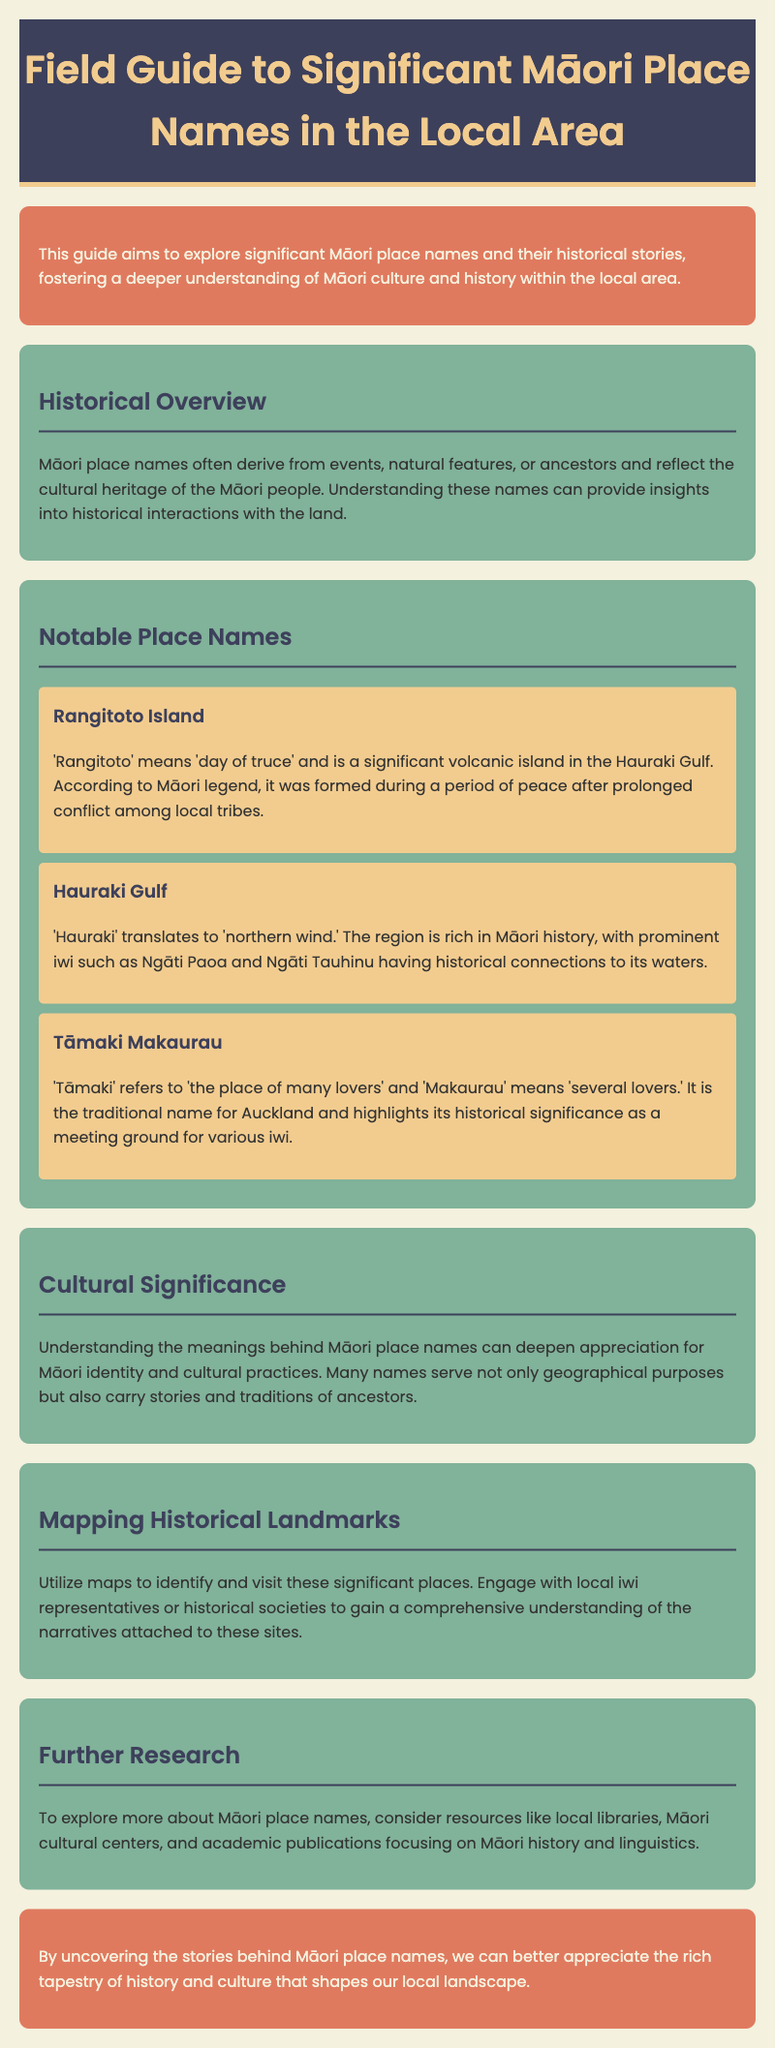What does 'Rangitoto' mean? 'Rangitoto' means 'day of truce' according to the document.
Answer: day of truce Which iwi are connected to the Hauraki Gulf? The document mentions Ngāti Paoa and Ngāti Tauhinu as iwi connected to the Hauraki Gulf.
Answer: Ngāti Paoa and Ngāti Tauhinu What is the traditional name for Auckland? The document states that 'Tāmaki Makaurau' is the traditional name for Auckland.
Answer: Tāmaki Makaurau What do Māori place names reflect? According to the document, Māori place names reflect the cultural heritage of the Māori people.
Answer: cultural heritage What is one method suggested in the document to understand significant places? The document suggests engaging with local iwi representatives or historical societies to gain understanding.
Answer: engage with local iwi representatives How does understanding Māori place names affect appreciation for Māori culture? The document explains that understanding the meanings behind Māori place names can deepen appreciation for Māori identity and cultural practices.
Answer: deepen appreciation What period does Rangitoto Island represent according to Māori legend? The document states that Rangitoto Island was formed during a period of peace after prolonged conflict among local tribes.
Answer: a period of peace Where can further research be conducted on Māori place names? The document suggests exploring local libraries, Māori cultural centers, and academic publications for further research.
Answer: local libraries, Māori cultural centers, and academic publications 